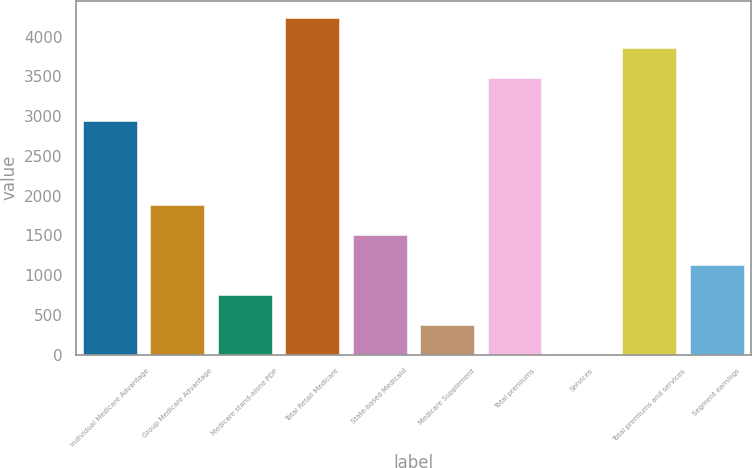Convert chart to OTSL. <chart><loc_0><loc_0><loc_500><loc_500><bar_chart><fcel>Individual Medicare Advantage<fcel>Group Medicare Advantage<fcel>Medicare stand-alone PDP<fcel>Total Retail Medicare<fcel>State-based Medicaid<fcel>Medicare Supplement<fcel>Total premiums<fcel>Services<fcel>Total premiums and services<fcel>Segment earnings<nl><fcel>2936<fcel>1883.5<fcel>754<fcel>4235<fcel>1507<fcel>377.5<fcel>3482<fcel>1<fcel>3858.5<fcel>1130.5<nl></chart> 